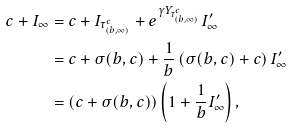Convert formula to latex. <formula><loc_0><loc_0><loc_500><loc_500>c + I _ { \infty } & = c + I _ { \tau ^ { c } _ { ( b , \infty ) } } + e ^ { \gamma Y _ { \tau ^ { c } _ { ( b , \infty ) } } } I _ { \infty } ^ { \prime } \\ & = c + \sigma ( b , c ) + \frac { 1 } { b } \left ( \sigma ( b , c ) + c \right ) I _ { \infty } ^ { \prime } \\ & = ( c + \sigma ( b , c ) ) \left ( 1 + \frac { 1 } { b } I _ { \infty } ^ { \prime } \right ) ,</formula> 